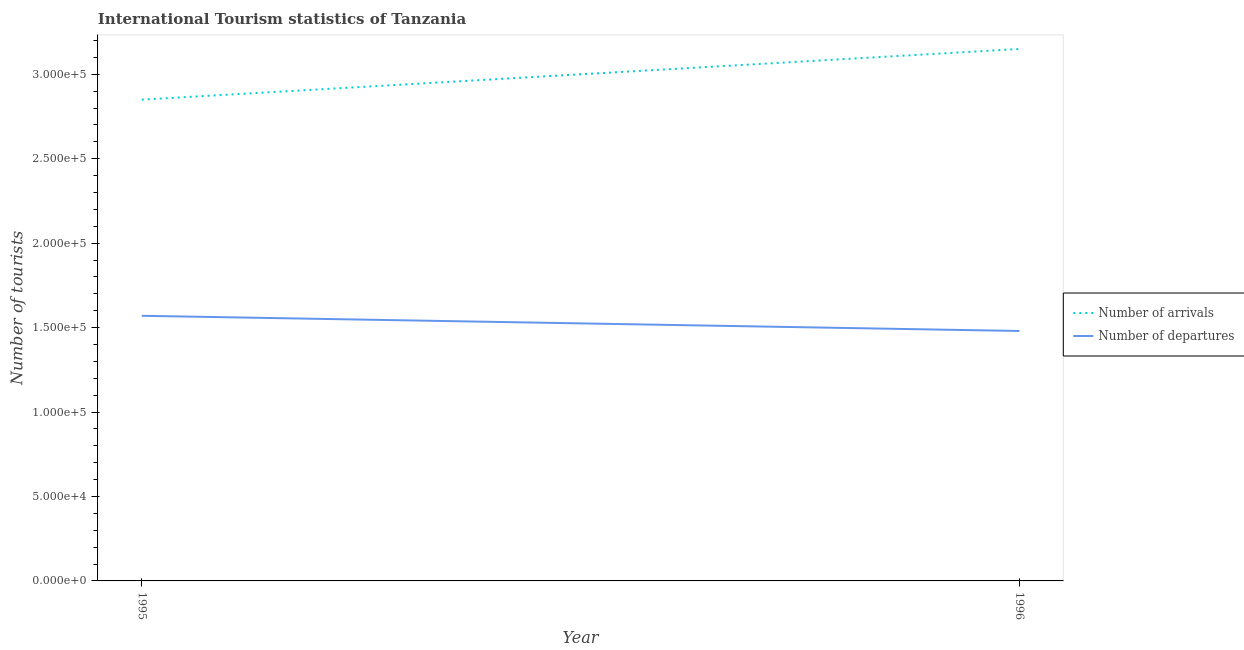Does the line corresponding to number of tourist arrivals intersect with the line corresponding to number of tourist departures?
Give a very brief answer. No. Is the number of lines equal to the number of legend labels?
Make the answer very short. Yes. What is the number of tourist arrivals in 1996?
Offer a terse response. 3.15e+05. Across all years, what is the maximum number of tourist arrivals?
Provide a short and direct response. 3.15e+05. Across all years, what is the minimum number of tourist arrivals?
Keep it short and to the point. 2.85e+05. In which year was the number of tourist arrivals maximum?
Keep it short and to the point. 1996. What is the total number of tourist departures in the graph?
Offer a terse response. 3.05e+05. What is the difference between the number of tourist arrivals in 1995 and that in 1996?
Provide a succinct answer. -3.00e+04. What is the difference between the number of tourist departures in 1996 and the number of tourist arrivals in 1995?
Provide a succinct answer. -1.37e+05. What is the average number of tourist departures per year?
Ensure brevity in your answer.  1.52e+05. In the year 1996, what is the difference between the number of tourist departures and number of tourist arrivals?
Provide a succinct answer. -1.67e+05. What is the ratio of the number of tourist arrivals in 1995 to that in 1996?
Your answer should be compact. 0.9. In how many years, is the number of tourist departures greater than the average number of tourist departures taken over all years?
Your answer should be very brief. 1. Is the number of tourist arrivals strictly less than the number of tourist departures over the years?
Your answer should be very brief. No. Does the graph contain any zero values?
Ensure brevity in your answer.  No. How many legend labels are there?
Your response must be concise. 2. How are the legend labels stacked?
Ensure brevity in your answer.  Vertical. What is the title of the graph?
Provide a succinct answer. International Tourism statistics of Tanzania. Does "Money lenders" appear as one of the legend labels in the graph?
Keep it short and to the point. No. What is the label or title of the Y-axis?
Keep it short and to the point. Number of tourists. What is the Number of tourists in Number of arrivals in 1995?
Provide a short and direct response. 2.85e+05. What is the Number of tourists of Number of departures in 1995?
Ensure brevity in your answer.  1.57e+05. What is the Number of tourists in Number of arrivals in 1996?
Make the answer very short. 3.15e+05. What is the Number of tourists in Number of departures in 1996?
Your response must be concise. 1.48e+05. Across all years, what is the maximum Number of tourists of Number of arrivals?
Offer a terse response. 3.15e+05. Across all years, what is the maximum Number of tourists in Number of departures?
Offer a terse response. 1.57e+05. Across all years, what is the minimum Number of tourists in Number of arrivals?
Your response must be concise. 2.85e+05. Across all years, what is the minimum Number of tourists in Number of departures?
Give a very brief answer. 1.48e+05. What is the total Number of tourists of Number of departures in the graph?
Keep it short and to the point. 3.05e+05. What is the difference between the Number of tourists in Number of arrivals in 1995 and that in 1996?
Offer a terse response. -3.00e+04. What is the difference between the Number of tourists in Number of departures in 1995 and that in 1996?
Give a very brief answer. 9000. What is the difference between the Number of tourists of Number of arrivals in 1995 and the Number of tourists of Number of departures in 1996?
Ensure brevity in your answer.  1.37e+05. What is the average Number of tourists in Number of arrivals per year?
Give a very brief answer. 3.00e+05. What is the average Number of tourists in Number of departures per year?
Ensure brevity in your answer.  1.52e+05. In the year 1995, what is the difference between the Number of tourists in Number of arrivals and Number of tourists in Number of departures?
Your answer should be compact. 1.28e+05. In the year 1996, what is the difference between the Number of tourists of Number of arrivals and Number of tourists of Number of departures?
Your answer should be compact. 1.67e+05. What is the ratio of the Number of tourists in Number of arrivals in 1995 to that in 1996?
Give a very brief answer. 0.9. What is the ratio of the Number of tourists of Number of departures in 1995 to that in 1996?
Your response must be concise. 1.06. What is the difference between the highest and the second highest Number of tourists of Number of departures?
Your answer should be very brief. 9000. What is the difference between the highest and the lowest Number of tourists in Number of departures?
Offer a terse response. 9000. 